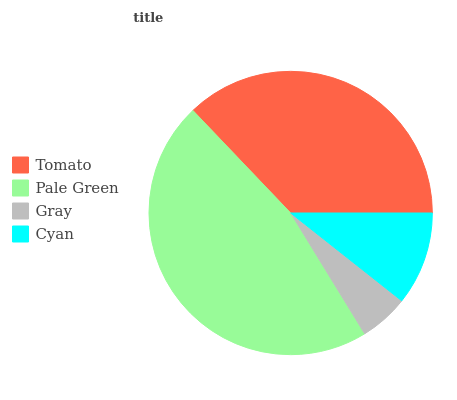Is Gray the minimum?
Answer yes or no. Yes. Is Pale Green the maximum?
Answer yes or no. Yes. Is Pale Green the minimum?
Answer yes or no. No. Is Gray the maximum?
Answer yes or no. No. Is Pale Green greater than Gray?
Answer yes or no. Yes. Is Gray less than Pale Green?
Answer yes or no. Yes. Is Gray greater than Pale Green?
Answer yes or no. No. Is Pale Green less than Gray?
Answer yes or no. No. Is Tomato the high median?
Answer yes or no. Yes. Is Cyan the low median?
Answer yes or no. Yes. Is Pale Green the high median?
Answer yes or no. No. Is Gray the low median?
Answer yes or no. No. 